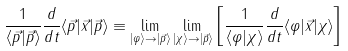<formula> <loc_0><loc_0><loc_500><loc_500>\frac { 1 } { \langle \vec { p } | \vec { p } \rangle } \frac { d } { d t } \langle \vec { p } | \vec { x } | \vec { p } \rangle \equiv \lim _ { | \varphi \rangle \to | \vec { p } \rangle } \lim _ { | \chi \rangle \to | \vec { p } \rangle } \left [ \frac { 1 } { \langle \varphi | \chi \rangle } \frac { d } { d t } \langle \varphi | \vec { x } | \chi \rangle \right ]</formula> 